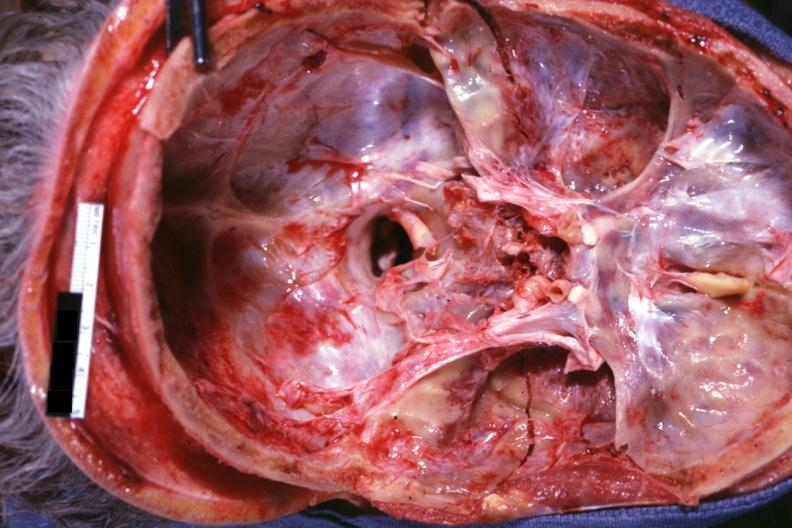what is present?
Answer the question using a single word or phrase. Bone, calvarium 